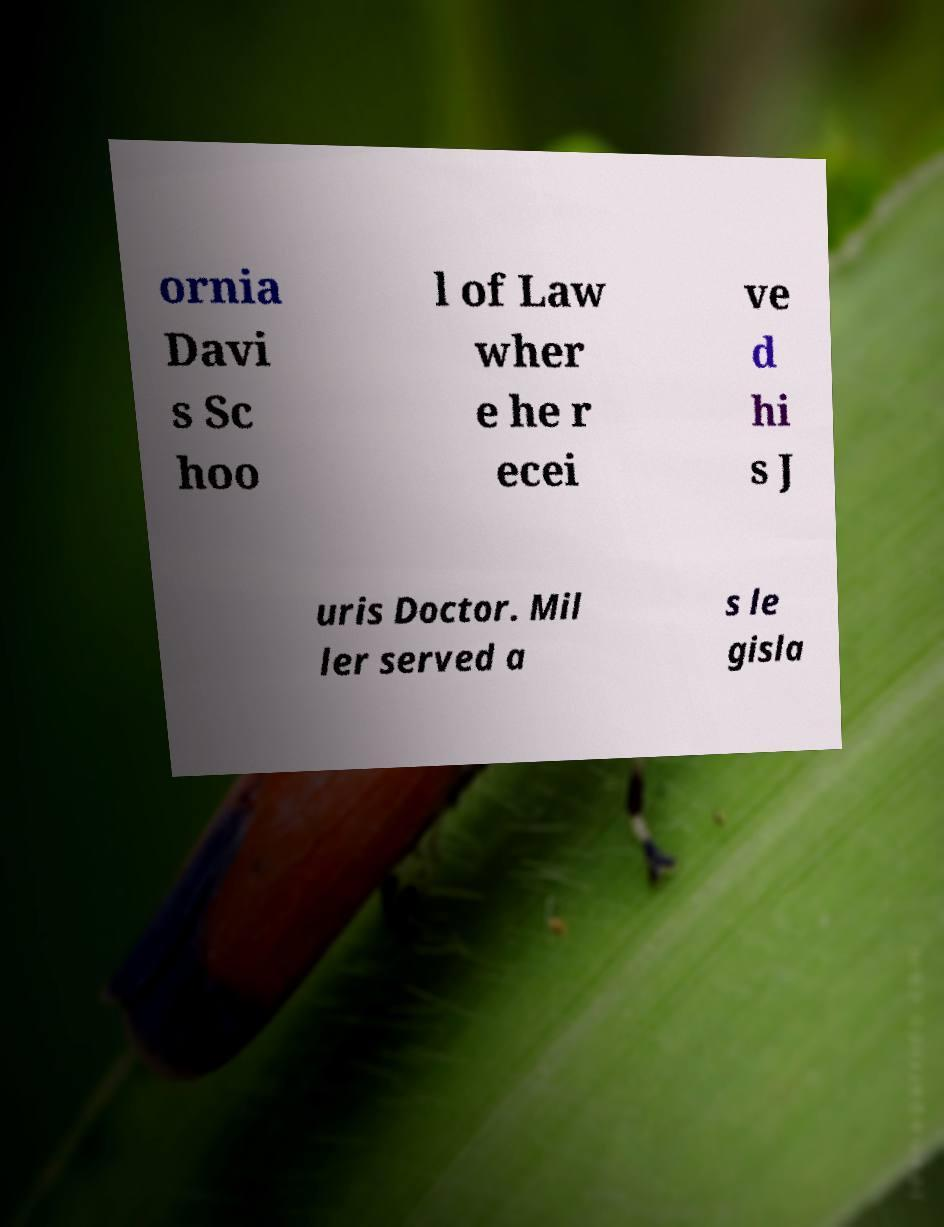Could you assist in decoding the text presented in this image and type it out clearly? ornia Davi s Sc hoo l of Law wher e he r ecei ve d hi s J uris Doctor. Mil ler served a s le gisla 